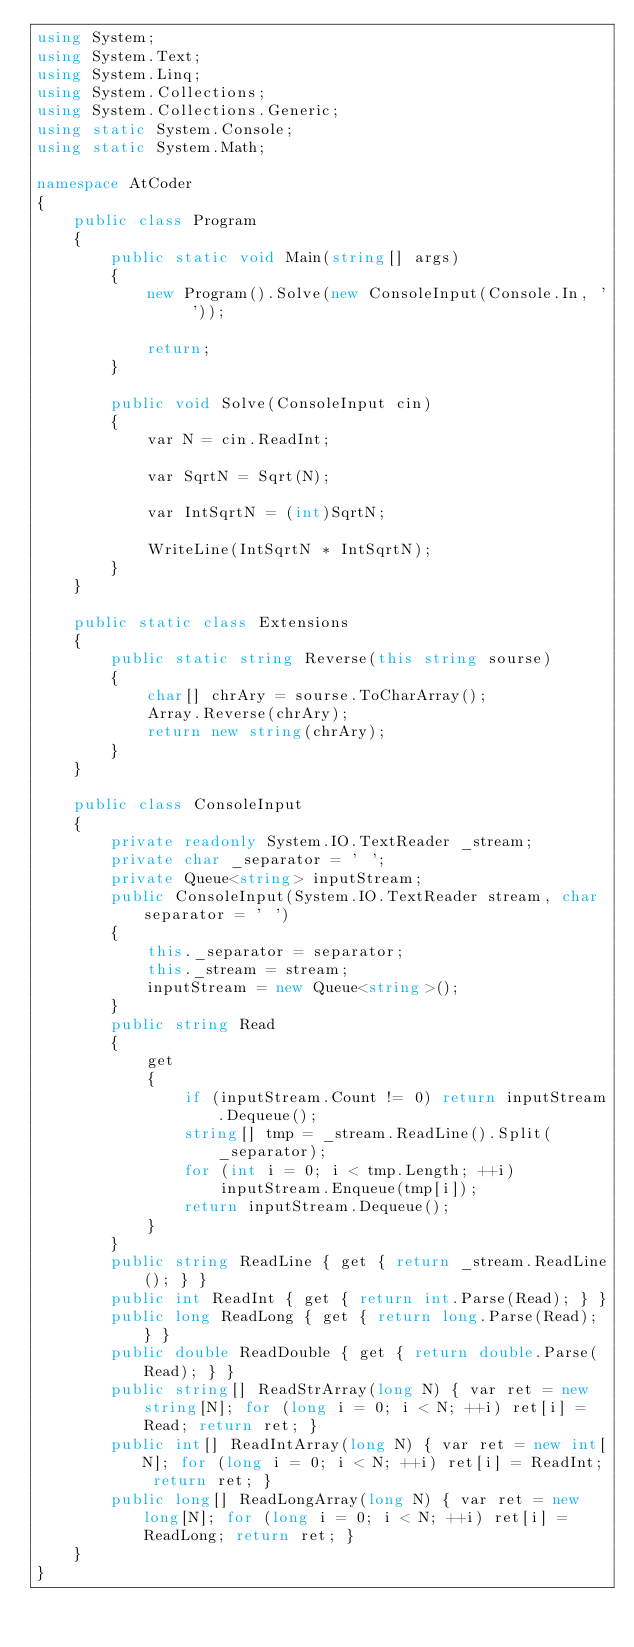<code> <loc_0><loc_0><loc_500><loc_500><_C#_>using System;
using System.Text;
using System.Linq;
using System.Collections;
using System.Collections.Generic;
using static System.Console;
using static System.Math;

namespace AtCoder
{
    public class Program
    {
        public static void Main(string[] args)
        {
            new Program().Solve(new ConsoleInput(Console.In, ' '));

            return;
        }

        public void Solve(ConsoleInput cin)
        {
            var N = cin.ReadInt;

            var SqrtN = Sqrt(N);

            var IntSqrtN = (int)SqrtN;

            WriteLine(IntSqrtN * IntSqrtN);
        }
    }

    public static class Extensions
    {
        public static string Reverse(this string sourse)
        {
            char[] chrAry = sourse.ToCharArray();
            Array.Reverse(chrAry);
            return new string(chrAry);
        }
    }

    public class ConsoleInput
    {
        private readonly System.IO.TextReader _stream;
        private char _separator = ' ';
        private Queue<string> inputStream;
        public ConsoleInput(System.IO.TextReader stream, char separator = ' ')
        {
            this._separator = separator;
            this._stream = stream;
            inputStream = new Queue<string>();
        }
        public string Read
        {
            get
            {
                if (inputStream.Count != 0) return inputStream.Dequeue();
                string[] tmp = _stream.ReadLine().Split(_separator);
                for (int i = 0; i < tmp.Length; ++i)
                    inputStream.Enqueue(tmp[i]);
                return inputStream.Dequeue();
            }
        }
        public string ReadLine { get { return _stream.ReadLine(); } }
        public int ReadInt { get { return int.Parse(Read); } }
        public long ReadLong { get { return long.Parse(Read); } }
        public double ReadDouble { get { return double.Parse(Read); } }
        public string[] ReadStrArray(long N) { var ret = new string[N]; for (long i = 0; i < N; ++i) ret[i] = Read; return ret; }
        public int[] ReadIntArray(long N) { var ret = new int[N]; for (long i = 0; i < N; ++i) ret[i] = ReadInt; return ret; }
        public long[] ReadLongArray(long N) { var ret = new long[N]; for (long i = 0; i < N; ++i) ret[i] = ReadLong; return ret; }
    }
}</code> 